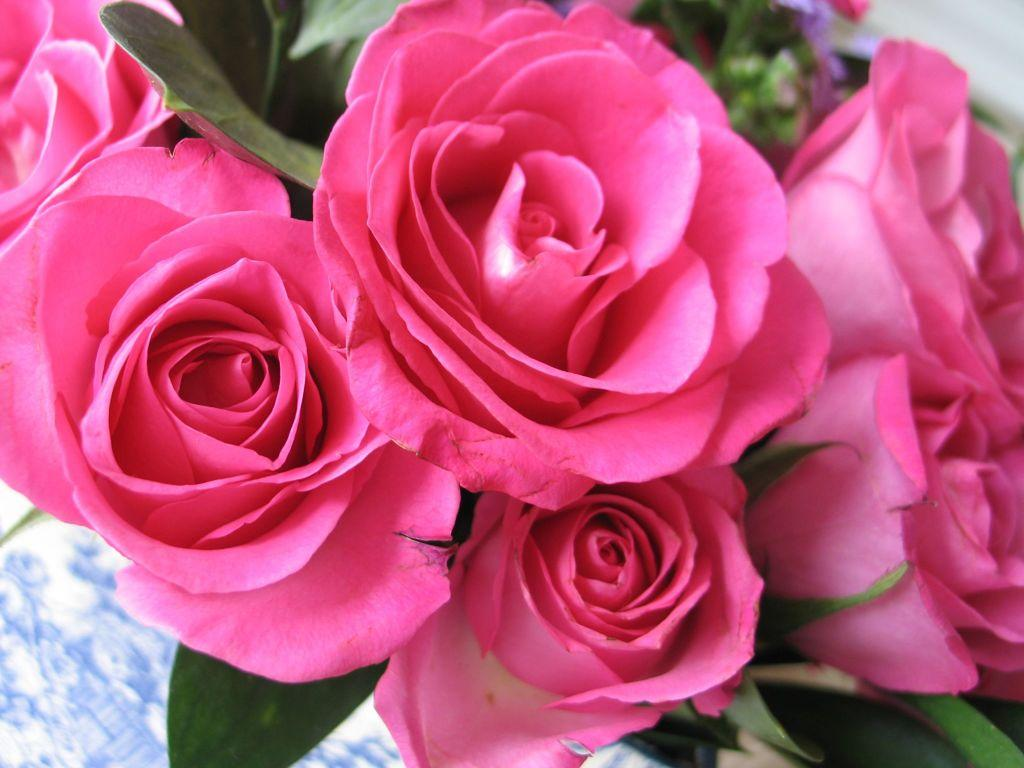What type of flowers are in the image? There are beautiful pink roses in the image. Can you describe the color of the roses? The roses are pink in color. Are there any cherries growing on the roses in the image? No, there are no cherries present in the image; it features pink roses. Does the existence of the roses in the image prove the existence of a higher power? The presence of roses in the image does not prove the existence of a higher power, as the image is a representation of a natural object and not a philosophical or religious statement. 